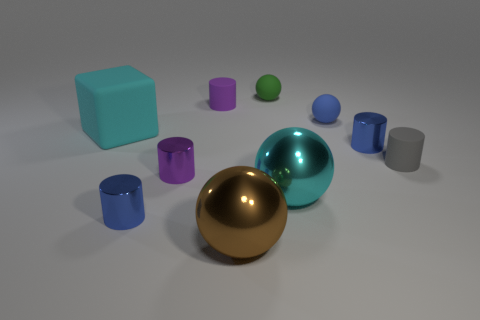There is a big cyan thing to the left of the purple metal cylinder; what is it made of?
Make the answer very short. Rubber. There is a blue object that is on the left side of the tiny matte cylinder that is on the left side of the large metallic thing behind the large brown shiny thing; what is its size?
Make the answer very short. Small. Do the cylinder behind the large cyan rubber cube and the small blue cylinder behind the gray thing have the same material?
Make the answer very short. No. How many other objects are the same color as the large cube?
Your response must be concise. 1. How many things are matte things that are in front of the large block or tiny cylinders on the right side of the brown sphere?
Your answer should be very brief. 2. What is the size of the thing that is behind the purple cylinder that is behind the blue rubber sphere?
Your answer should be very brief. Small. What is the size of the blue rubber sphere?
Provide a short and direct response. Small. Is the color of the matte cylinder that is in front of the cyan cube the same as the small metal thing that is right of the small purple metallic cylinder?
Your answer should be very brief. No. How many other things are made of the same material as the big cyan cube?
Provide a succinct answer. 4. Are any cyan rubber cubes visible?
Ensure brevity in your answer.  Yes. 